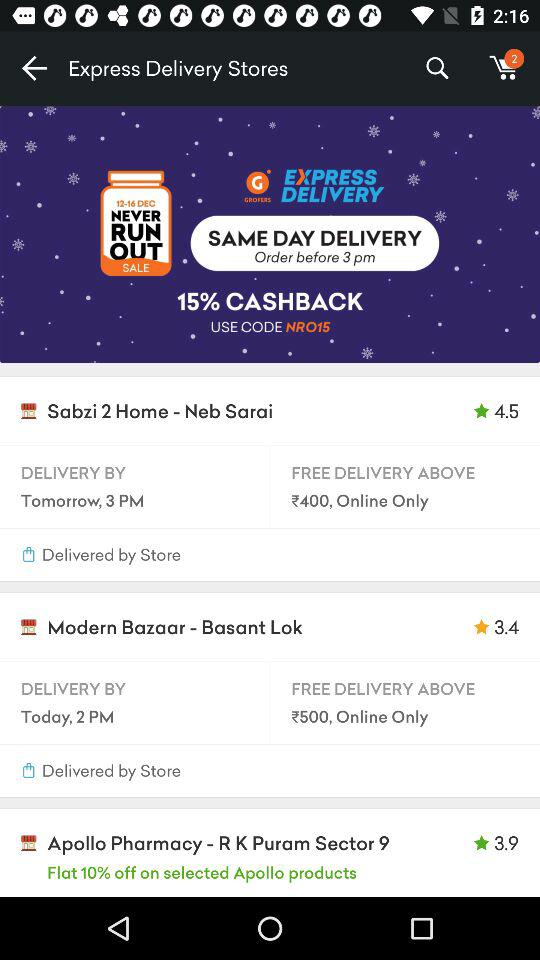Which store has the lowest rating?
Answer the question using a single word or phrase. Modern Bazaar - Basant Lok 